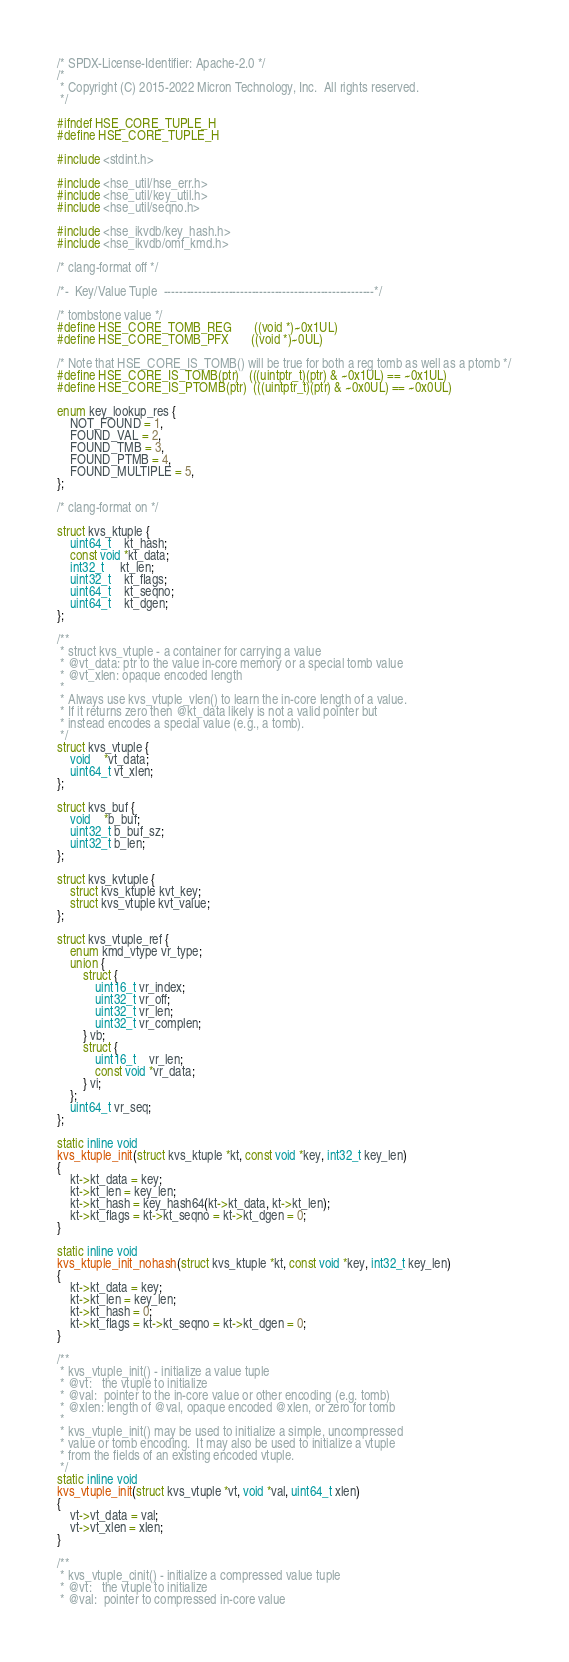<code> <loc_0><loc_0><loc_500><loc_500><_C_>/* SPDX-License-Identifier: Apache-2.0 */
/*
 * Copyright (C) 2015-2022 Micron Technology, Inc.  All rights reserved.
 */

#ifndef HSE_CORE_TUPLE_H
#define HSE_CORE_TUPLE_H

#include <stdint.h>

#include <hse_util/hse_err.h>
#include <hse_util/key_util.h>
#include <hse_util/seqno.h>

#include <hse_ikvdb/key_hash.h>
#include <hse_ikvdb/omf_kmd.h>

/* clang-format off */

/*-  Key/Value Tuple  -------------------------------------------------------*/

/* tombstone value */
#define HSE_CORE_TOMB_REG       ((void *)~0x1UL)
#define HSE_CORE_TOMB_PFX       ((void *)~0UL)

/* Note that HSE_CORE_IS_TOMB() will be true for both a reg tomb as well as a ptomb */
#define HSE_CORE_IS_TOMB(ptr)   (((uintptr_t)(ptr) & ~0x1UL) == ~0x1UL)
#define HSE_CORE_IS_PTOMB(ptr)  (((uintptr_t)(ptr) & ~0x0UL) == ~0x0UL)

enum key_lookup_res {
    NOT_FOUND = 1,
    FOUND_VAL = 2,
    FOUND_TMB = 3,
    FOUND_PTMB = 4,
    FOUND_MULTIPLE = 5,
};

/* clang-format on */

struct kvs_ktuple {
    uint64_t    kt_hash;
    const void *kt_data;
    int32_t     kt_len;
    uint32_t    kt_flags;
    uint64_t    kt_seqno;
    uint64_t    kt_dgen;
};

/**
 * struct kvs_vtuple - a container for carrying a value
 * @vt_data: ptr to the value in-core memory or a special tomb value
 * @vt_xlen: opaque encoded length
 *
 * Always use kvs_vtuple_vlen() to learn the in-core length of a value.
 * If it returns zero then @kt_data likely is not a valid pointer but
 * instead encodes a special value (e.g., a tomb).
 */
struct kvs_vtuple {
    void    *vt_data;
    uint64_t vt_xlen;
};

struct kvs_buf {
    void    *b_buf;
    uint32_t b_buf_sz;
    uint32_t b_len;
};

struct kvs_kvtuple {
    struct kvs_ktuple kvt_key;
    struct kvs_vtuple kvt_value;
};

struct kvs_vtuple_ref {
    enum kmd_vtype vr_type;
    union {
        struct {
            uint16_t vr_index;
            uint32_t vr_off;
            uint32_t vr_len;
            uint32_t vr_complen;
        } vb;
        struct {
            uint16_t    vr_len;
            const void *vr_data;
        } vi;
    };
    uint64_t vr_seq;
};

static inline void
kvs_ktuple_init(struct kvs_ktuple *kt, const void *key, int32_t key_len)
{
    kt->kt_data = key;
    kt->kt_len = key_len;
    kt->kt_hash = key_hash64(kt->kt_data, kt->kt_len);
    kt->kt_flags = kt->kt_seqno = kt->kt_dgen = 0;
}

static inline void
kvs_ktuple_init_nohash(struct kvs_ktuple *kt, const void *key, int32_t key_len)
{
    kt->kt_data = key;
    kt->kt_len = key_len;
    kt->kt_hash = 0;
    kt->kt_flags = kt->kt_seqno = kt->kt_dgen = 0;
}

/**
 * kvs_vtuple_init() - initialize a value tuple
 * @vt:   the vtuple to initialize
 * @val:  pointer to the in-core value or other encoding (e.g. tomb)
 * @xlen: length of @val, opaque encoded @xlen, or zero for tomb
 *
 * kvs_vtuple_init() may be used to initialize a simple, uncompressed
 * value or tomb encoding.  It may also be used to initialize a vtuple
 * from the fields of an existing encoded vtuple.
 */
static inline void
kvs_vtuple_init(struct kvs_vtuple *vt, void *val, uint64_t xlen)
{
    vt->vt_data = val;
    vt->vt_xlen = xlen;
}

/**
 * kvs_vtuple_cinit() - initialize a compressed value tuple
 * @vt:   the vtuple to initialize
 * @val:  pointer to compressed in-core value</code> 